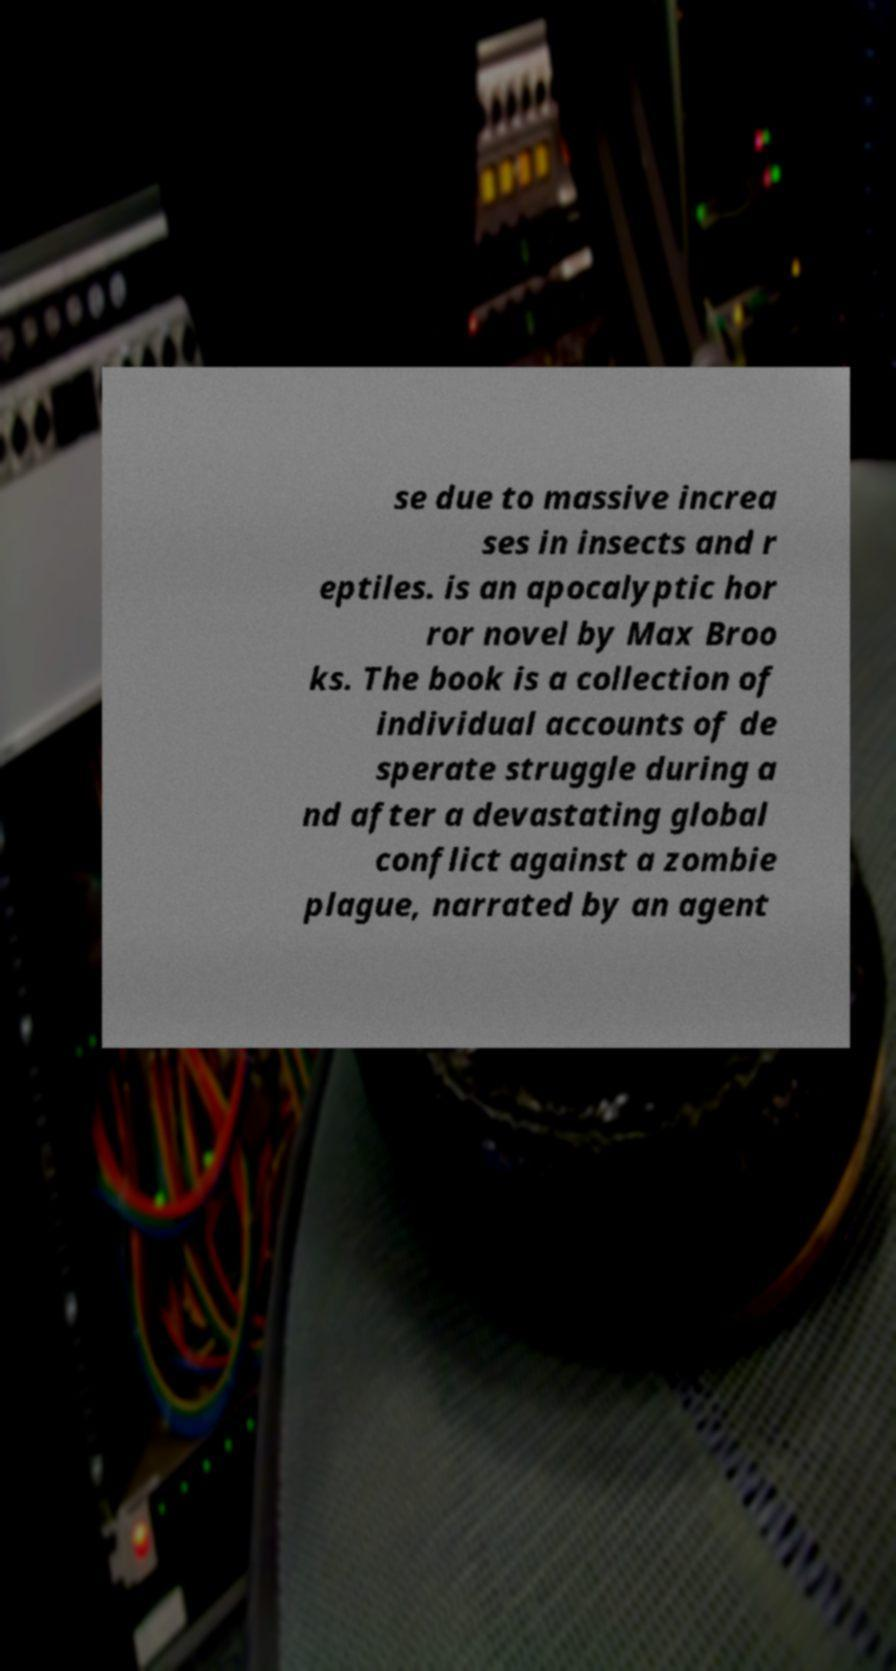What messages or text are displayed in this image? I need them in a readable, typed format. se due to massive increa ses in insects and r eptiles. is an apocalyptic hor ror novel by Max Broo ks. The book is a collection of individual accounts of de sperate struggle during a nd after a devastating global conflict against a zombie plague, narrated by an agent 